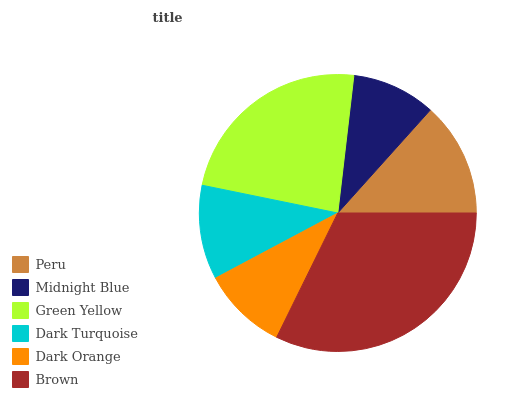Is Midnight Blue the minimum?
Answer yes or no. Yes. Is Brown the maximum?
Answer yes or no. Yes. Is Green Yellow the minimum?
Answer yes or no. No. Is Green Yellow the maximum?
Answer yes or no. No. Is Green Yellow greater than Midnight Blue?
Answer yes or no. Yes. Is Midnight Blue less than Green Yellow?
Answer yes or no. Yes. Is Midnight Blue greater than Green Yellow?
Answer yes or no. No. Is Green Yellow less than Midnight Blue?
Answer yes or no. No. Is Peru the high median?
Answer yes or no. Yes. Is Dark Turquoise the low median?
Answer yes or no. Yes. Is Green Yellow the high median?
Answer yes or no. No. Is Dark Orange the low median?
Answer yes or no. No. 